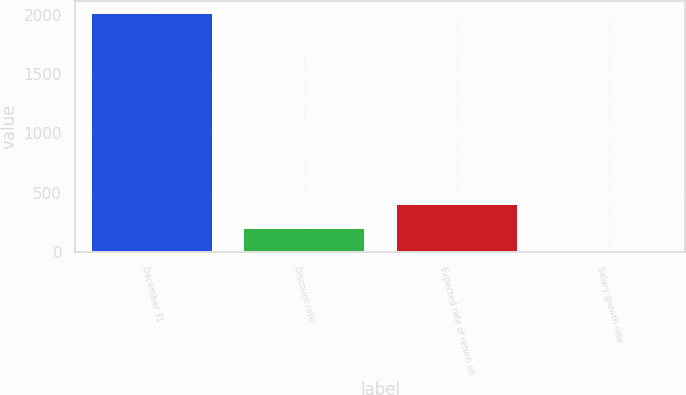Convert chart. <chart><loc_0><loc_0><loc_500><loc_500><bar_chart><fcel>December 31<fcel>Discount rate<fcel>Expected rate of return on<fcel>Salary growth rate<nl><fcel>2012<fcel>205.25<fcel>406<fcel>4.5<nl></chart> 